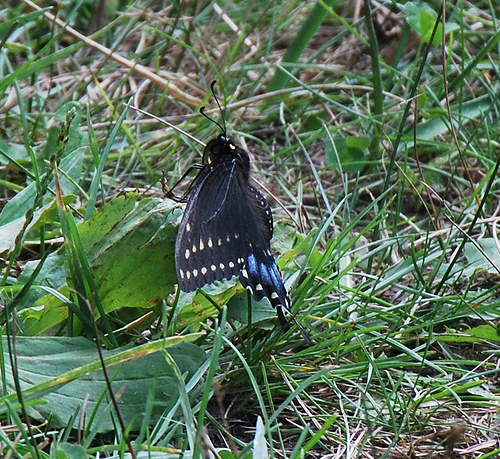<image>
Is there a moth behind the leaf? No. The moth is not behind the leaf. From this viewpoint, the moth appears to be positioned elsewhere in the scene. Where is the butterfly in relation to the grass? Is it to the right of the grass? No. The butterfly is not to the right of the grass. The horizontal positioning shows a different relationship. 